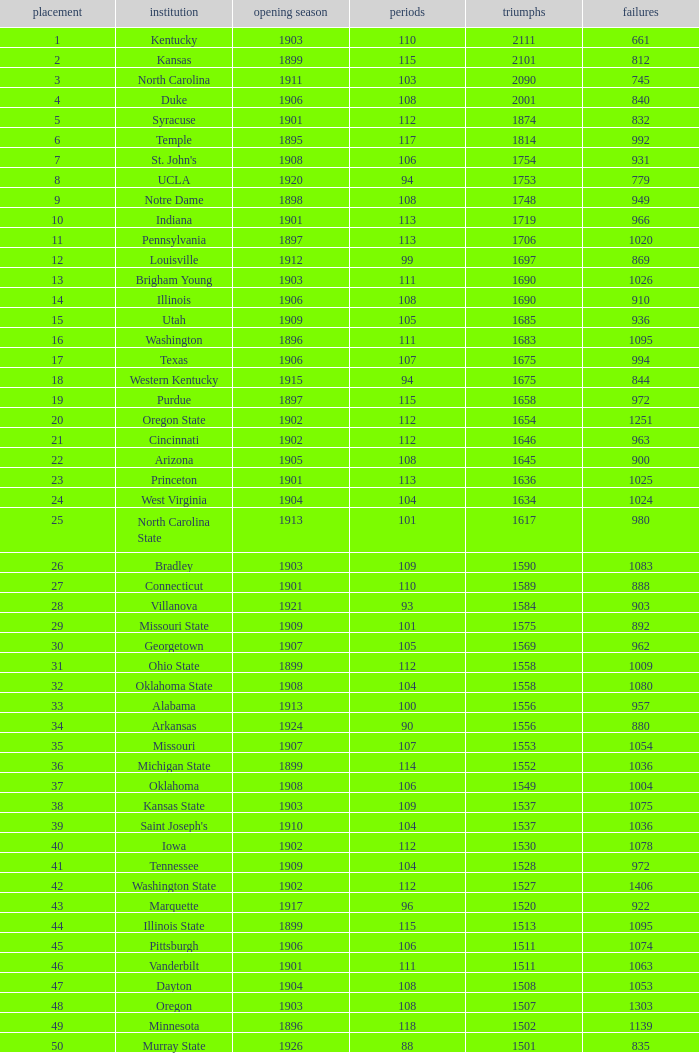What is the total of First Season games with 1537 Wins and a Season greater than 109? None. 